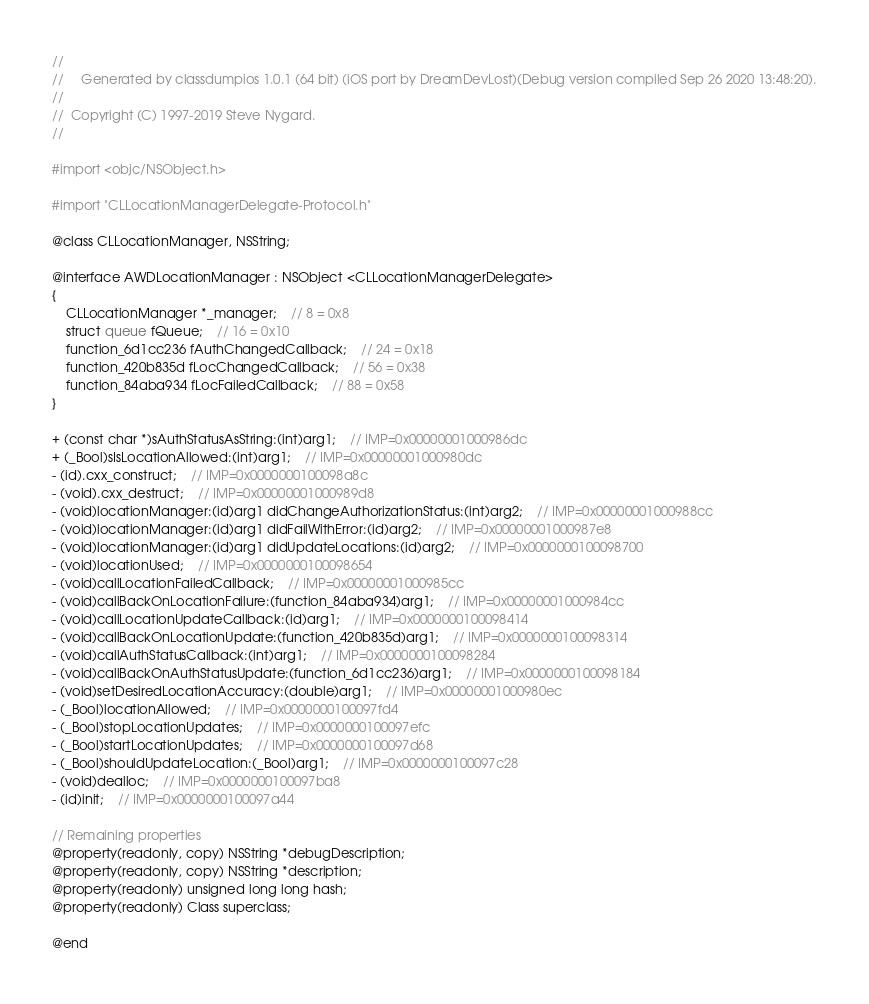<code> <loc_0><loc_0><loc_500><loc_500><_C_>//
//     Generated by classdumpios 1.0.1 (64 bit) (iOS port by DreamDevLost)(Debug version compiled Sep 26 2020 13:48:20).
//
//  Copyright (C) 1997-2019 Steve Nygard.
//

#import <objc/NSObject.h>

#import "CLLocationManagerDelegate-Protocol.h"

@class CLLocationManager, NSString;

@interface AWDLocationManager : NSObject <CLLocationManagerDelegate>
{
    CLLocationManager *_manager;	// 8 = 0x8
    struct queue fQueue;	// 16 = 0x10
    function_6d1cc236 fAuthChangedCallback;	// 24 = 0x18
    function_420b835d fLocChangedCallback;	// 56 = 0x38
    function_84aba934 fLocFailedCallback;	// 88 = 0x58
}

+ (const char *)sAuthStatusAsString:(int)arg1;	// IMP=0x00000001000986dc
+ (_Bool)sIsLocationAllowed:(int)arg1;	// IMP=0x00000001000980dc
- (id).cxx_construct;	// IMP=0x0000000100098a8c
- (void).cxx_destruct;	// IMP=0x00000001000989d8
- (void)locationManager:(id)arg1 didChangeAuthorizationStatus:(int)arg2;	// IMP=0x00000001000988cc
- (void)locationManager:(id)arg1 didFailWithError:(id)arg2;	// IMP=0x00000001000987e8
- (void)locationManager:(id)arg1 didUpdateLocations:(id)arg2;	// IMP=0x0000000100098700
- (void)locationUsed;	// IMP=0x0000000100098654
- (void)callLocationFailedCallback;	// IMP=0x00000001000985cc
- (void)callBackOnLocationFailure:(function_84aba934)arg1;	// IMP=0x00000001000984cc
- (void)callLocationUpdateCallback:(id)arg1;	// IMP=0x0000000100098414
- (void)callBackOnLocationUpdate:(function_420b835d)arg1;	// IMP=0x0000000100098314
- (void)callAuthStatusCallback:(int)arg1;	// IMP=0x0000000100098284
- (void)callBackOnAuthStatusUpdate:(function_6d1cc236)arg1;	// IMP=0x0000000100098184
- (void)setDesiredLocationAccuracy:(double)arg1;	// IMP=0x00000001000980ec
- (_Bool)locationAllowed;	// IMP=0x0000000100097fd4
- (_Bool)stopLocationUpdates;	// IMP=0x0000000100097efc
- (_Bool)startLocationUpdates;	// IMP=0x0000000100097d68
- (_Bool)shouldUpdateLocation:(_Bool)arg1;	// IMP=0x0000000100097c28
- (void)dealloc;	// IMP=0x0000000100097ba8
- (id)init;	// IMP=0x0000000100097a44

// Remaining properties
@property(readonly, copy) NSString *debugDescription;
@property(readonly, copy) NSString *description;
@property(readonly) unsigned long long hash;
@property(readonly) Class superclass;

@end

</code> 